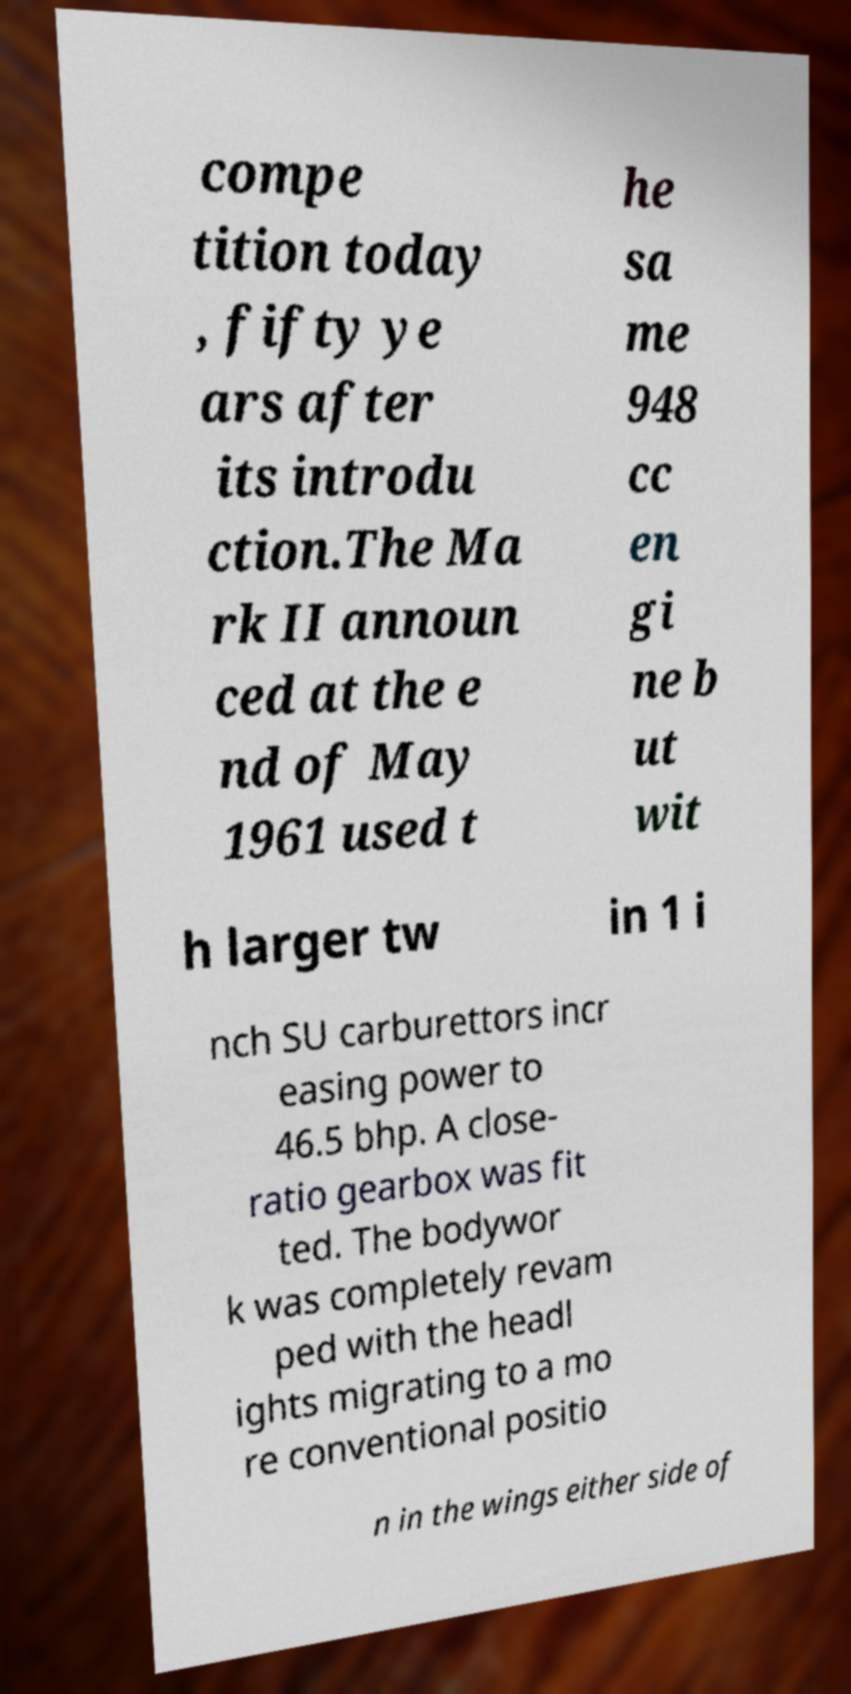Please identify and transcribe the text found in this image. compe tition today , fifty ye ars after its introdu ction.The Ma rk II announ ced at the e nd of May 1961 used t he sa me 948 cc en gi ne b ut wit h larger tw in 1 i nch SU carburettors incr easing power to 46.5 bhp. A close- ratio gearbox was fit ted. The bodywor k was completely revam ped with the headl ights migrating to a mo re conventional positio n in the wings either side of 